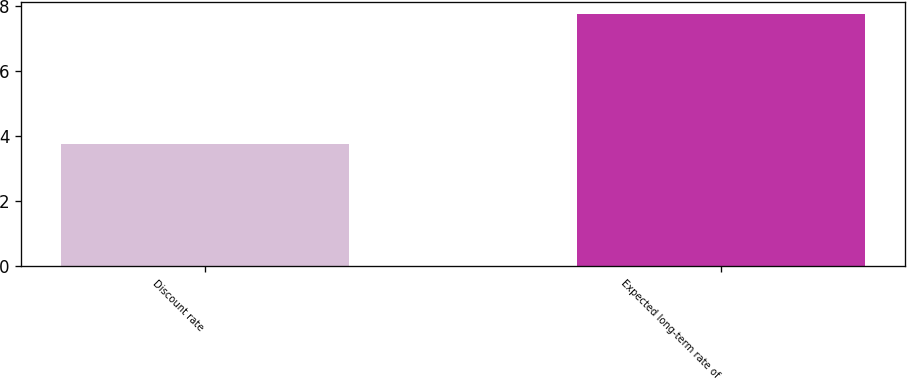<chart> <loc_0><loc_0><loc_500><loc_500><bar_chart><fcel>Discount rate<fcel>Expected long-term rate of<nl><fcel>3.75<fcel>7.75<nl></chart> 